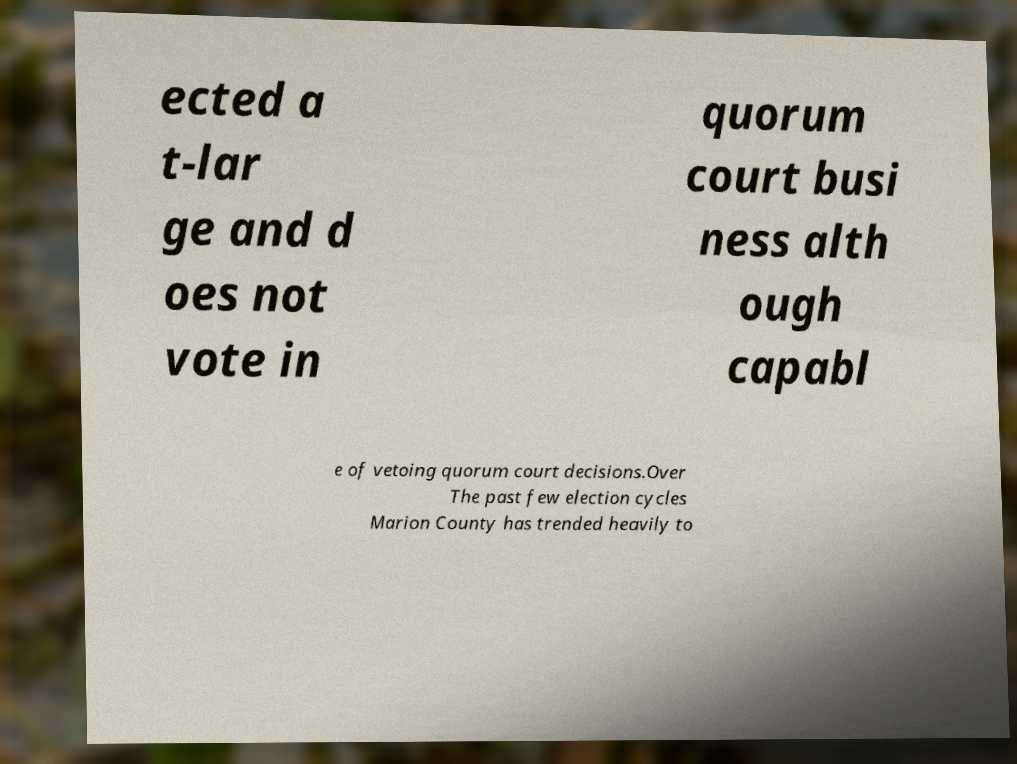What messages or text are displayed in this image? I need them in a readable, typed format. ected a t-lar ge and d oes not vote in quorum court busi ness alth ough capabl e of vetoing quorum court decisions.Over The past few election cycles Marion County has trended heavily to 